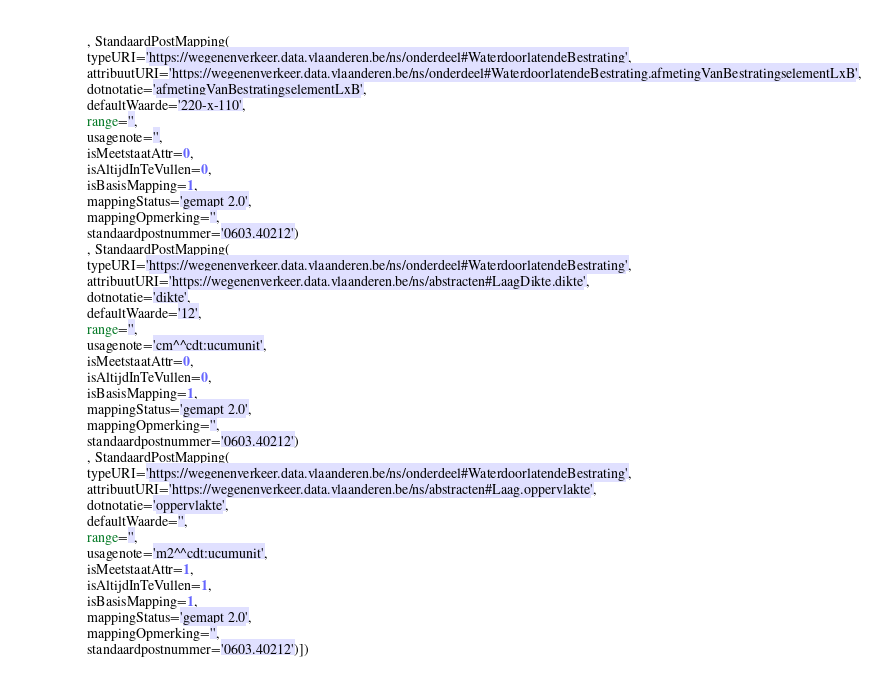<code> <loc_0><loc_0><loc_500><loc_500><_Python_>                , StandaardPostMapping(
                typeURI='https://wegenenverkeer.data.vlaanderen.be/ns/onderdeel#WaterdoorlatendeBestrating',
                attribuutURI='https://wegenenverkeer.data.vlaanderen.be/ns/onderdeel#WaterdoorlatendeBestrating.afmetingVanBestratingselementLxB',
                dotnotatie='afmetingVanBestratingselementLxB',
                defaultWaarde='220-x-110',
                range='',
                usagenote='',
                isMeetstaatAttr=0,
                isAltijdInTeVullen=0,
                isBasisMapping=1,
                mappingStatus='gemapt 2.0',
                mappingOpmerking='',
                standaardpostnummer='0603.40212')
                , StandaardPostMapping(
                typeURI='https://wegenenverkeer.data.vlaanderen.be/ns/onderdeel#WaterdoorlatendeBestrating',
                attribuutURI='https://wegenenverkeer.data.vlaanderen.be/ns/abstracten#LaagDikte.dikte',
                dotnotatie='dikte',
                defaultWaarde='12',
                range='',
                usagenote='cm^^cdt:ucumunit',
                isMeetstaatAttr=0,
                isAltijdInTeVullen=0,
                isBasisMapping=1,
                mappingStatus='gemapt 2.0',
                mappingOpmerking='',
                standaardpostnummer='0603.40212')
                , StandaardPostMapping(
                typeURI='https://wegenenverkeer.data.vlaanderen.be/ns/onderdeel#WaterdoorlatendeBestrating',
                attribuutURI='https://wegenenverkeer.data.vlaanderen.be/ns/abstracten#Laag.oppervlakte',
                dotnotatie='oppervlakte',
                defaultWaarde='',
                range='',
                usagenote='m2^^cdt:ucumunit',
                isMeetstaatAttr=1,
                isAltijdInTeVullen=1,
                isBasisMapping=1,
                mappingStatus='gemapt 2.0',
                mappingOpmerking='',
                standaardpostnummer='0603.40212')])
</code> 